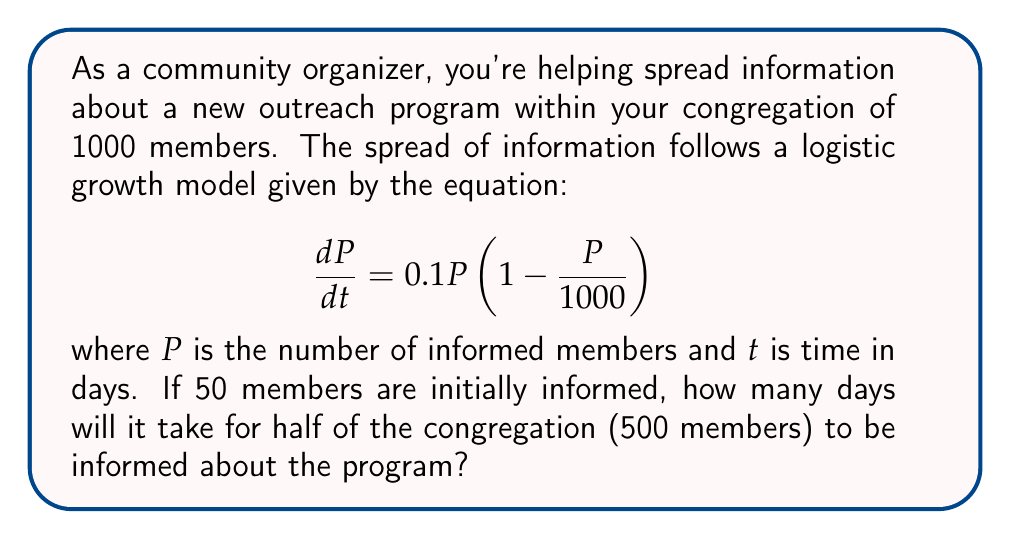Can you solve this math problem? To solve this problem, we'll use the logistic equation and its solution:

1) The given logistic equation is:
   $$\frac{dP}{dt} = 0.1P(1 - \frac{P}{1000})$$

2) The solution to this logistic equation is:
   $$P(t) = \frac{1000}{1 + (\frac{1000}{P_0} - 1)e^{-0.1t}}$$
   where $P_0$ is the initial population.

3) We're given that $P_0 = 50$ and we want to find $t$ when $P(t) = 500$.

4) Substituting these values into the solution:
   $$500 = \frac{1000}{1 + (\frac{1000}{50} - 1)e^{-0.1t}}$$

5) Simplifying:
   $$500 = \frac{1000}{1 + 19e^{-0.1t}}$$

6) Multiplying both sides by $(1 + 19e^{-0.1t})$:
   $$500 + 9500e^{-0.1t} = 1000$$

7) Subtracting 500 from both sides:
   $$9500e^{-0.1t} = 500$$

8) Dividing both sides by 9500:
   $$e^{-0.1t} = \frac{1}{19}$$

9) Taking the natural log of both sides:
   $$-0.1t = \ln(\frac{1}{19})$$

10) Dividing both sides by -0.1:
    $$t = -10\ln(\frac{1}{19}) \approx 29.7$$

Therefore, it will take approximately 29.7 days for half of the congregation to be informed.
Answer: 29.7 days 